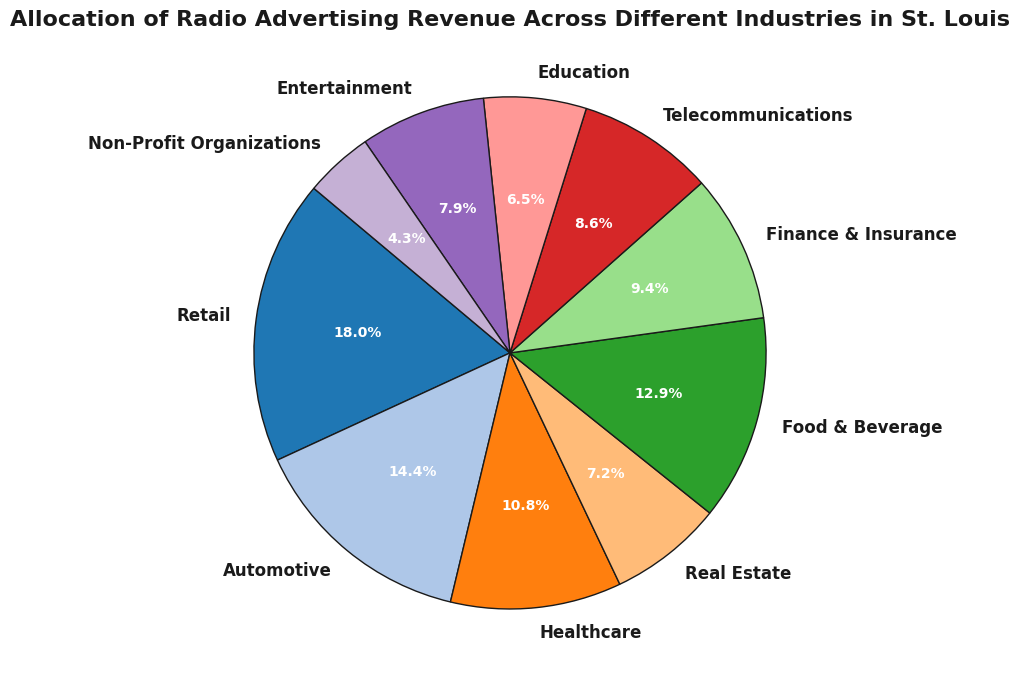What percentage of the total revenue is contributed by the "Retail" industry? First, identify the "Retail" section in the pie chart, then read the percentage label directly from the chart.
Answer: 23.0% How does the revenue of the "Automotive" industry compare to the "Healthcare" industry? Identify the slices representing "Automotive" and "Healthcare". The "Automotive" slice is larger than the "Healthcare" slice, indicating that "Automotive" has a higher revenue contribution.
Answer: Automotive > Healthcare What is the total percentage of revenue contributed by "Food & Beverage" and "Finance & Insurance"? Locate the labels for "Food & Beverage" and "Finance & Insurance", read their percentages, and sum them up (16.6% + 12.0%).
Answer: 28.6% Which industry has the lowest revenue contribution, and what is the percentage? Find the smallest slice in the pie chart and read its label and percentage. The smallest slice is "Non-Profit Organizations".
Answer: Non-Profit Organizations, 5.5% Are there any industries that contribute equally to the radio advertising revenue? If yes, which ones? Look for slices in the pie chart that have the same percentage values. Both "Real Estate" and "Education" contribute 8.3%.
Answer: Real Estate and Education Between "Telecommunications" and "Entertainment", which industry has a higher revenue, and by how much? Identify both "Telecommunications" and "Entertainment" slices, compare their sizes and percentages (Telecommunications: 11.0%, Entertainment: 10.2%). Subtract the percentages (12.0% - 10.1%).
Answer: Telecommunications by 0.8% What is the combined revenue percentage for the top three industries? Identify and sum the top three largest slices: Retail (23.0%), Automotive (18.3%), Food & Beverage (16.6%).
Answer: 49.9% What is the combined contribution percentage of "Telecommunications", "Education", and "Entertainment"? Sum their percentages as indicated by the pie chart (11.0% + 8.3% + 10.1%).
Answer: 29.4% Which industry has a larger share: "Real Estate" or "Finance & Insurance"? Compare the percentages of both industries. "Finance & Insurance" is larger than "Real Estate".
Answer: Finance & Insurance What percentage of the total revenue is contributed by industries other than "Retail" and "Automotive"? Subtract the combined percentage of "Retail" and "Automotive" from 100% (100% - 41.4%).
Answer: 58.6% 